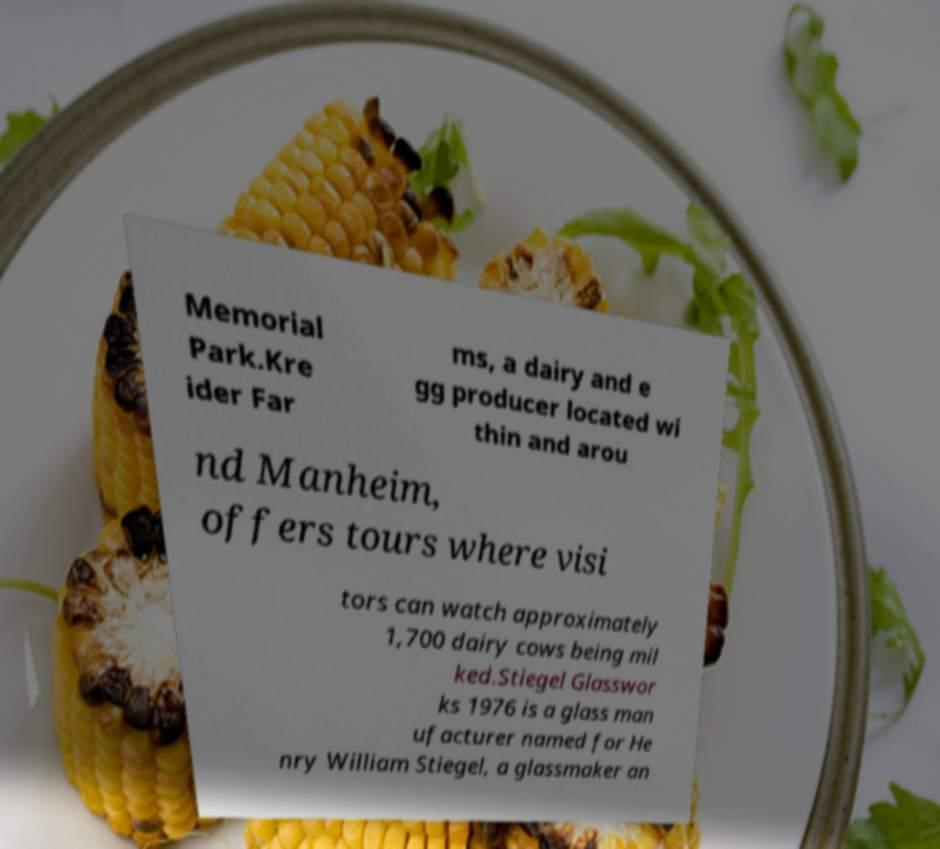Could you assist in decoding the text presented in this image and type it out clearly? Memorial Park.Kre ider Far ms, a dairy and e gg producer located wi thin and arou nd Manheim, offers tours where visi tors can watch approximately 1,700 dairy cows being mil ked.Stiegel Glasswor ks 1976 is a glass man ufacturer named for He nry William Stiegel, a glassmaker an 